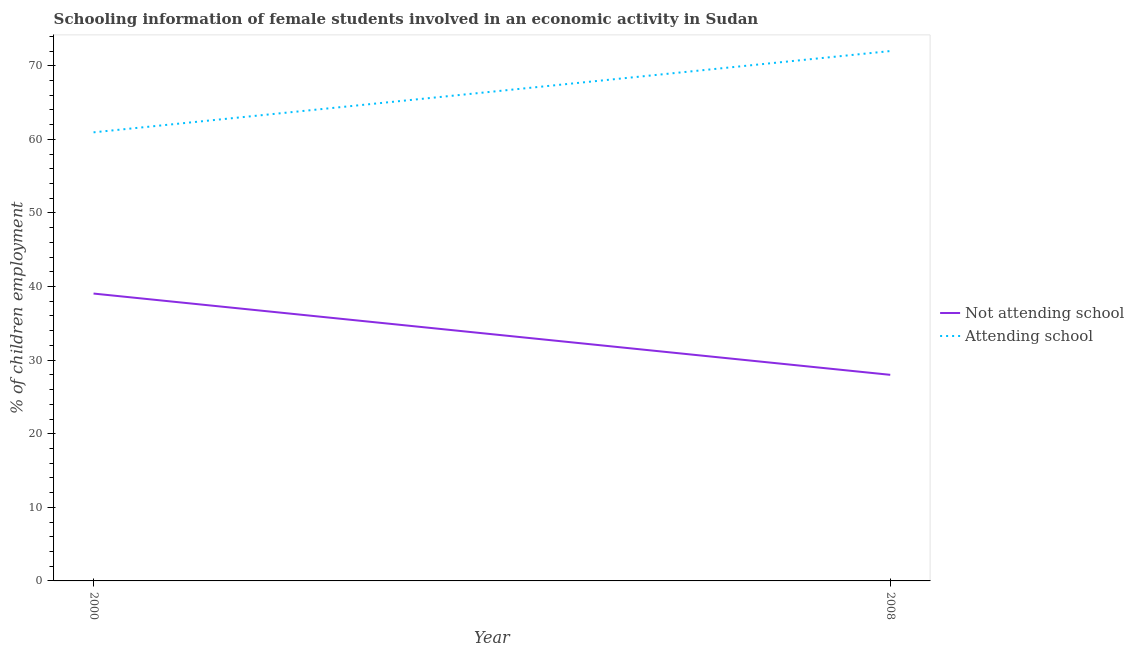Does the line corresponding to percentage of employed females who are not attending school intersect with the line corresponding to percentage of employed females who are attending school?
Offer a terse response. No. Is the number of lines equal to the number of legend labels?
Ensure brevity in your answer.  Yes. What is the percentage of employed females who are not attending school in 2008?
Give a very brief answer. 28. Across all years, what is the maximum percentage of employed females who are attending school?
Offer a very short reply. 72. Across all years, what is the minimum percentage of employed females who are attending school?
Offer a very short reply. 60.95. In which year was the percentage of employed females who are attending school maximum?
Provide a succinct answer. 2008. What is the total percentage of employed females who are not attending school in the graph?
Your answer should be very brief. 67.05. What is the difference between the percentage of employed females who are not attending school in 2000 and that in 2008?
Offer a terse response. 11.04. What is the difference between the percentage of employed females who are attending school in 2008 and the percentage of employed females who are not attending school in 2000?
Your answer should be compact. 32.95. What is the average percentage of employed females who are attending school per year?
Offer a terse response. 66.48. In the year 2000, what is the difference between the percentage of employed females who are not attending school and percentage of employed females who are attending school?
Keep it short and to the point. -21.91. What is the ratio of the percentage of employed females who are attending school in 2000 to that in 2008?
Your answer should be very brief. 0.85. Is the percentage of employed females who are attending school in 2000 less than that in 2008?
Provide a succinct answer. Yes. Does the percentage of employed females who are attending school monotonically increase over the years?
Offer a very short reply. Yes. Is the percentage of employed females who are attending school strictly greater than the percentage of employed females who are not attending school over the years?
Ensure brevity in your answer.  Yes. Is the percentage of employed females who are attending school strictly less than the percentage of employed females who are not attending school over the years?
Ensure brevity in your answer.  No. How many lines are there?
Ensure brevity in your answer.  2. What is the difference between two consecutive major ticks on the Y-axis?
Provide a succinct answer. 10. Does the graph contain any zero values?
Give a very brief answer. No. Does the graph contain grids?
Your answer should be very brief. No. Where does the legend appear in the graph?
Your response must be concise. Center right. How are the legend labels stacked?
Give a very brief answer. Vertical. What is the title of the graph?
Provide a short and direct response. Schooling information of female students involved in an economic activity in Sudan. What is the label or title of the Y-axis?
Keep it short and to the point. % of children employment. What is the % of children employment in Not attending school in 2000?
Your answer should be very brief. 39.05. What is the % of children employment in Attending school in 2000?
Offer a terse response. 60.95. What is the % of children employment of Not attending school in 2008?
Provide a succinct answer. 28. What is the % of children employment of Attending school in 2008?
Your answer should be very brief. 72. Across all years, what is the maximum % of children employment in Not attending school?
Keep it short and to the point. 39.05. Across all years, what is the maximum % of children employment in Attending school?
Ensure brevity in your answer.  72. Across all years, what is the minimum % of children employment in Not attending school?
Make the answer very short. 28. Across all years, what is the minimum % of children employment in Attending school?
Provide a short and direct response. 60.95. What is the total % of children employment of Not attending school in the graph?
Make the answer very short. 67.05. What is the total % of children employment in Attending school in the graph?
Offer a terse response. 132.95. What is the difference between the % of children employment in Not attending school in 2000 and that in 2008?
Your response must be concise. 11.04. What is the difference between the % of children employment of Attending school in 2000 and that in 2008?
Provide a short and direct response. -11.04. What is the difference between the % of children employment in Not attending school in 2000 and the % of children employment in Attending school in 2008?
Your answer should be very brief. -32.95. What is the average % of children employment in Not attending school per year?
Keep it short and to the point. 33.52. What is the average % of children employment of Attending school per year?
Your answer should be very brief. 66.48. In the year 2000, what is the difference between the % of children employment in Not attending school and % of children employment in Attending school?
Provide a succinct answer. -21.91. In the year 2008, what is the difference between the % of children employment in Not attending school and % of children employment in Attending school?
Offer a terse response. -43.99. What is the ratio of the % of children employment in Not attending school in 2000 to that in 2008?
Keep it short and to the point. 1.39. What is the ratio of the % of children employment of Attending school in 2000 to that in 2008?
Make the answer very short. 0.85. What is the difference between the highest and the second highest % of children employment of Not attending school?
Your answer should be compact. 11.04. What is the difference between the highest and the second highest % of children employment of Attending school?
Offer a terse response. 11.04. What is the difference between the highest and the lowest % of children employment of Not attending school?
Ensure brevity in your answer.  11.04. What is the difference between the highest and the lowest % of children employment in Attending school?
Keep it short and to the point. 11.04. 